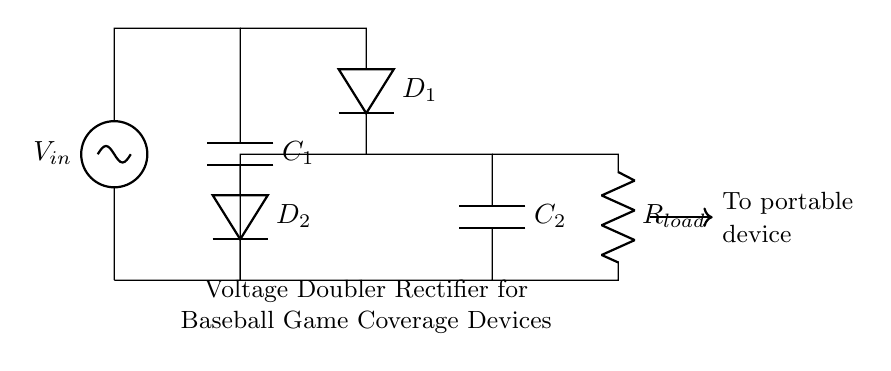What is the input voltage of this circuit? The input voltage is indicated at the top of the circuit diagram with the label V_in.
Answer: V_in What are the types of capacitors used in the circuit? The circuit includes two capacitors labeled C_1 and C_2, both of which are marked in the diagram.
Answer: C_1 and C_2 How many diodes are present in this rectifier circuit? There are two diodes labeled D_1 and D_2, which can be counted from the diagram.
Answer: 2 What is the purpose of the diodes in this circuit? The diodes D_1 and D_2 allow current to flow in one direction, facilitating the rectification process and creating a voltage doubler effect.
Answer: Rectification How does the voltage doubler circuit deliver power to the load? The capacitors charge up to a voltage that is double the input, and the load connected (R_load) receives this doubled voltage through the configuration of diodes and capacitors.
Answer: Through R_load What is the function of the capacitor labeled C_2? Capacitor C_2 holds the rectified output voltage, stabilizing it for the load while also aiding in the voltage doubling effect.
Answer: Voltage stabilization What type of load is connected to this circuit? The load connected is referred to as R_load in the circuit, which represents the portable device that will be charged using this voltage doubling rectifier.
Answer: Portable device 